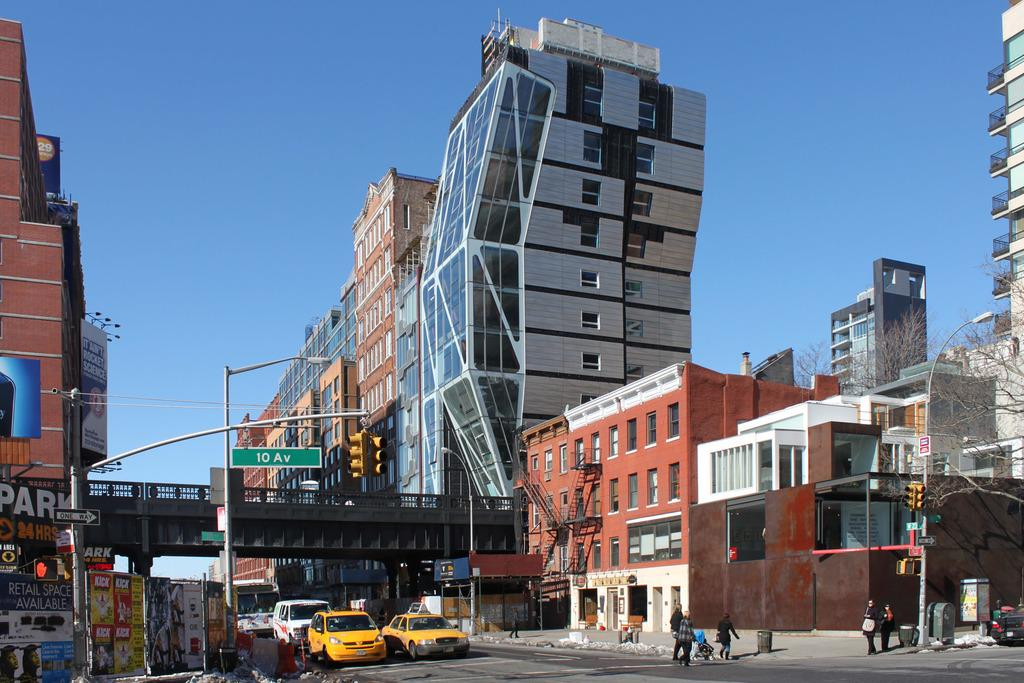Provide a one-sentence caption for the provided image. Retail space is available on 10 Av according to the sign. 